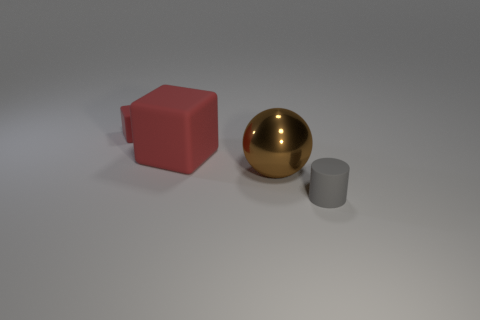Add 3 tiny red shiny things. How many objects exist? 7 Subtract all cylinders. How many objects are left? 3 Add 3 tiny red cubes. How many tiny red cubes exist? 4 Subtract 0 cyan cubes. How many objects are left? 4 Subtract all large gray metallic things. Subtract all large things. How many objects are left? 2 Add 3 rubber cylinders. How many rubber cylinders are left? 4 